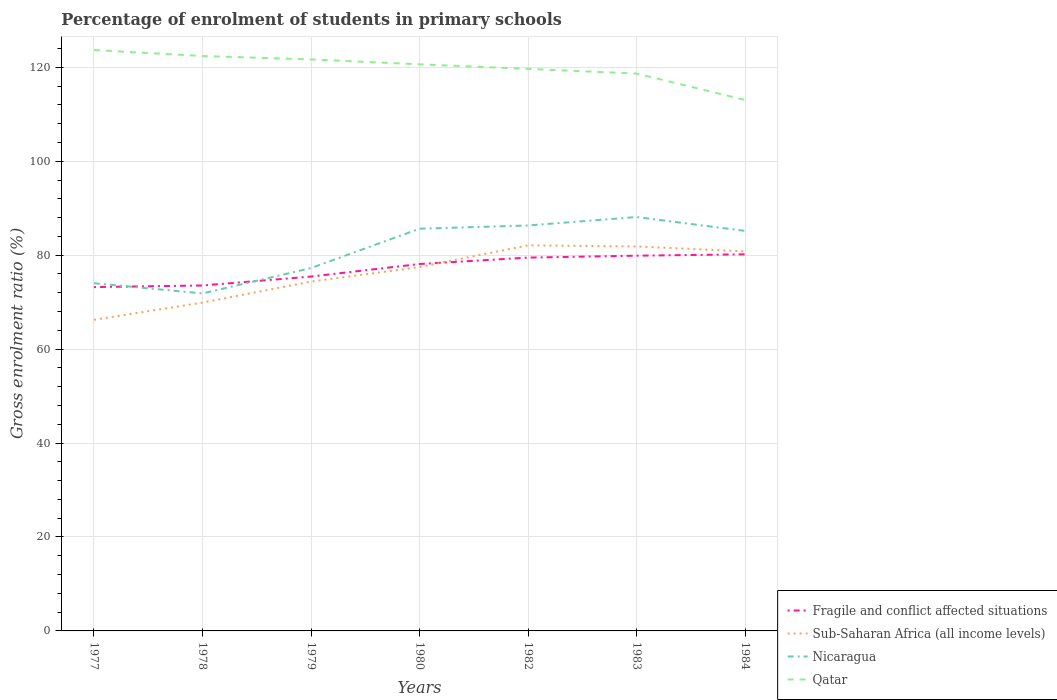Is the number of lines equal to the number of legend labels?
Your answer should be compact. Yes. Across all years, what is the maximum percentage of students enrolled in primary schools in Qatar?
Ensure brevity in your answer.  113.06. What is the total percentage of students enrolled in primary schools in Sub-Saharan Africa (all income levels) in the graph?
Provide a succinct answer. -7.72. What is the difference between the highest and the second highest percentage of students enrolled in primary schools in Fragile and conflict affected situations?
Your answer should be very brief. 6.98. What is the difference between the highest and the lowest percentage of students enrolled in primary schools in Fragile and conflict affected situations?
Give a very brief answer. 4. How many lines are there?
Offer a terse response. 4. Are the values on the major ticks of Y-axis written in scientific E-notation?
Your answer should be compact. No. Where does the legend appear in the graph?
Keep it short and to the point. Bottom right. How many legend labels are there?
Provide a short and direct response. 4. How are the legend labels stacked?
Keep it short and to the point. Vertical. What is the title of the graph?
Your answer should be compact. Percentage of enrolment of students in primary schools. Does "Lower middle income" appear as one of the legend labels in the graph?
Your response must be concise. No. What is the Gross enrolment ratio (%) in Fragile and conflict affected situations in 1977?
Offer a terse response. 73.21. What is the Gross enrolment ratio (%) of Sub-Saharan Africa (all income levels) in 1977?
Offer a terse response. 66.25. What is the Gross enrolment ratio (%) in Nicaragua in 1977?
Ensure brevity in your answer.  74.04. What is the Gross enrolment ratio (%) of Qatar in 1977?
Ensure brevity in your answer.  123.68. What is the Gross enrolment ratio (%) in Fragile and conflict affected situations in 1978?
Offer a very short reply. 73.55. What is the Gross enrolment ratio (%) of Sub-Saharan Africa (all income levels) in 1978?
Your answer should be very brief. 69.91. What is the Gross enrolment ratio (%) of Nicaragua in 1978?
Keep it short and to the point. 71.86. What is the Gross enrolment ratio (%) in Qatar in 1978?
Offer a terse response. 122.42. What is the Gross enrolment ratio (%) of Fragile and conflict affected situations in 1979?
Provide a succinct answer. 75.46. What is the Gross enrolment ratio (%) of Sub-Saharan Africa (all income levels) in 1979?
Keep it short and to the point. 74.39. What is the Gross enrolment ratio (%) of Nicaragua in 1979?
Make the answer very short. 77.27. What is the Gross enrolment ratio (%) in Qatar in 1979?
Make the answer very short. 121.69. What is the Gross enrolment ratio (%) of Fragile and conflict affected situations in 1980?
Offer a terse response. 78.13. What is the Gross enrolment ratio (%) of Sub-Saharan Africa (all income levels) in 1980?
Give a very brief answer. 77.48. What is the Gross enrolment ratio (%) in Nicaragua in 1980?
Provide a succinct answer. 85.64. What is the Gross enrolment ratio (%) of Qatar in 1980?
Give a very brief answer. 120.65. What is the Gross enrolment ratio (%) in Fragile and conflict affected situations in 1982?
Your answer should be compact. 79.49. What is the Gross enrolment ratio (%) in Sub-Saharan Africa (all income levels) in 1982?
Provide a short and direct response. 82.11. What is the Gross enrolment ratio (%) in Nicaragua in 1982?
Give a very brief answer. 86.33. What is the Gross enrolment ratio (%) in Qatar in 1982?
Offer a very short reply. 119.67. What is the Gross enrolment ratio (%) in Fragile and conflict affected situations in 1983?
Provide a succinct answer. 79.9. What is the Gross enrolment ratio (%) in Sub-Saharan Africa (all income levels) in 1983?
Ensure brevity in your answer.  81.86. What is the Gross enrolment ratio (%) in Nicaragua in 1983?
Your answer should be very brief. 88.13. What is the Gross enrolment ratio (%) in Qatar in 1983?
Offer a terse response. 118.68. What is the Gross enrolment ratio (%) in Fragile and conflict affected situations in 1984?
Give a very brief answer. 80.2. What is the Gross enrolment ratio (%) of Sub-Saharan Africa (all income levels) in 1984?
Make the answer very short. 80.81. What is the Gross enrolment ratio (%) of Nicaragua in 1984?
Your response must be concise. 85.18. What is the Gross enrolment ratio (%) of Qatar in 1984?
Offer a terse response. 113.06. Across all years, what is the maximum Gross enrolment ratio (%) in Fragile and conflict affected situations?
Provide a succinct answer. 80.2. Across all years, what is the maximum Gross enrolment ratio (%) of Sub-Saharan Africa (all income levels)?
Provide a succinct answer. 82.11. Across all years, what is the maximum Gross enrolment ratio (%) in Nicaragua?
Offer a terse response. 88.13. Across all years, what is the maximum Gross enrolment ratio (%) of Qatar?
Provide a short and direct response. 123.68. Across all years, what is the minimum Gross enrolment ratio (%) in Fragile and conflict affected situations?
Offer a terse response. 73.21. Across all years, what is the minimum Gross enrolment ratio (%) in Sub-Saharan Africa (all income levels)?
Give a very brief answer. 66.25. Across all years, what is the minimum Gross enrolment ratio (%) in Nicaragua?
Offer a terse response. 71.86. Across all years, what is the minimum Gross enrolment ratio (%) of Qatar?
Your answer should be compact. 113.06. What is the total Gross enrolment ratio (%) in Fragile and conflict affected situations in the graph?
Your answer should be very brief. 539.94. What is the total Gross enrolment ratio (%) of Sub-Saharan Africa (all income levels) in the graph?
Ensure brevity in your answer.  532.8. What is the total Gross enrolment ratio (%) of Nicaragua in the graph?
Your response must be concise. 568.45. What is the total Gross enrolment ratio (%) in Qatar in the graph?
Make the answer very short. 839.85. What is the difference between the Gross enrolment ratio (%) of Fragile and conflict affected situations in 1977 and that in 1978?
Your answer should be very brief. -0.34. What is the difference between the Gross enrolment ratio (%) of Sub-Saharan Africa (all income levels) in 1977 and that in 1978?
Keep it short and to the point. -3.66. What is the difference between the Gross enrolment ratio (%) in Nicaragua in 1977 and that in 1978?
Your answer should be compact. 2.18. What is the difference between the Gross enrolment ratio (%) in Qatar in 1977 and that in 1978?
Offer a very short reply. 1.27. What is the difference between the Gross enrolment ratio (%) of Fragile and conflict affected situations in 1977 and that in 1979?
Your answer should be very brief. -2.24. What is the difference between the Gross enrolment ratio (%) of Sub-Saharan Africa (all income levels) in 1977 and that in 1979?
Provide a short and direct response. -8.14. What is the difference between the Gross enrolment ratio (%) in Nicaragua in 1977 and that in 1979?
Make the answer very short. -3.23. What is the difference between the Gross enrolment ratio (%) of Qatar in 1977 and that in 1979?
Give a very brief answer. 1.99. What is the difference between the Gross enrolment ratio (%) in Fragile and conflict affected situations in 1977 and that in 1980?
Offer a terse response. -4.91. What is the difference between the Gross enrolment ratio (%) of Sub-Saharan Africa (all income levels) in 1977 and that in 1980?
Keep it short and to the point. -11.23. What is the difference between the Gross enrolment ratio (%) in Nicaragua in 1977 and that in 1980?
Offer a terse response. -11.6. What is the difference between the Gross enrolment ratio (%) in Qatar in 1977 and that in 1980?
Keep it short and to the point. 3.03. What is the difference between the Gross enrolment ratio (%) in Fragile and conflict affected situations in 1977 and that in 1982?
Offer a very short reply. -6.28. What is the difference between the Gross enrolment ratio (%) in Sub-Saharan Africa (all income levels) in 1977 and that in 1982?
Ensure brevity in your answer.  -15.86. What is the difference between the Gross enrolment ratio (%) in Nicaragua in 1977 and that in 1982?
Give a very brief answer. -12.29. What is the difference between the Gross enrolment ratio (%) of Qatar in 1977 and that in 1982?
Ensure brevity in your answer.  4.01. What is the difference between the Gross enrolment ratio (%) of Fragile and conflict affected situations in 1977 and that in 1983?
Provide a short and direct response. -6.68. What is the difference between the Gross enrolment ratio (%) of Sub-Saharan Africa (all income levels) in 1977 and that in 1983?
Your answer should be compact. -15.61. What is the difference between the Gross enrolment ratio (%) of Nicaragua in 1977 and that in 1983?
Offer a very short reply. -14.09. What is the difference between the Gross enrolment ratio (%) in Qatar in 1977 and that in 1983?
Give a very brief answer. 5. What is the difference between the Gross enrolment ratio (%) of Fragile and conflict affected situations in 1977 and that in 1984?
Your answer should be compact. -6.98. What is the difference between the Gross enrolment ratio (%) of Sub-Saharan Africa (all income levels) in 1977 and that in 1984?
Give a very brief answer. -14.56. What is the difference between the Gross enrolment ratio (%) in Nicaragua in 1977 and that in 1984?
Ensure brevity in your answer.  -11.14. What is the difference between the Gross enrolment ratio (%) of Qatar in 1977 and that in 1984?
Offer a terse response. 10.63. What is the difference between the Gross enrolment ratio (%) in Fragile and conflict affected situations in 1978 and that in 1979?
Provide a short and direct response. -1.9. What is the difference between the Gross enrolment ratio (%) in Sub-Saharan Africa (all income levels) in 1978 and that in 1979?
Provide a succinct answer. -4.48. What is the difference between the Gross enrolment ratio (%) of Nicaragua in 1978 and that in 1979?
Offer a terse response. -5.41. What is the difference between the Gross enrolment ratio (%) of Qatar in 1978 and that in 1979?
Ensure brevity in your answer.  0.73. What is the difference between the Gross enrolment ratio (%) of Fragile and conflict affected situations in 1978 and that in 1980?
Offer a terse response. -4.57. What is the difference between the Gross enrolment ratio (%) in Sub-Saharan Africa (all income levels) in 1978 and that in 1980?
Your response must be concise. -7.57. What is the difference between the Gross enrolment ratio (%) of Nicaragua in 1978 and that in 1980?
Ensure brevity in your answer.  -13.78. What is the difference between the Gross enrolment ratio (%) in Qatar in 1978 and that in 1980?
Make the answer very short. 1.77. What is the difference between the Gross enrolment ratio (%) in Fragile and conflict affected situations in 1978 and that in 1982?
Offer a terse response. -5.94. What is the difference between the Gross enrolment ratio (%) in Sub-Saharan Africa (all income levels) in 1978 and that in 1982?
Ensure brevity in your answer.  -12.2. What is the difference between the Gross enrolment ratio (%) of Nicaragua in 1978 and that in 1982?
Keep it short and to the point. -14.47. What is the difference between the Gross enrolment ratio (%) in Qatar in 1978 and that in 1982?
Your response must be concise. 2.74. What is the difference between the Gross enrolment ratio (%) in Fragile and conflict affected situations in 1978 and that in 1983?
Your answer should be very brief. -6.34. What is the difference between the Gross enrolment ratio (%) of Sub-Saharan Africa (all income levels) in 1978 and that in 1983?
Offer a very short reply. -11.95. What is the difference between the Gross enrolment ratio (%) of Nicaragua in 1978 and that in 1983?
Your answer should be very brief. -16.27. What is the difference between the Gross enrolment ratio (%) of Qatar in 1978 and that in 1983?
Provide a succinct answer. 3.73. What is the difference between the Gross enrolment ratio (%) of Fragile and conflict affected situations in 1978 and that in 1984?
Your answer should be very brief. -6.64. What is the difference between the Gross enrolment ratio (%) in Sub-Saharan Africa (all income levels) in 1978 and that in 1984?
Offer a terse response. -10.9. What is the difference between the Gross enrolment ratio (%) in Nicaragua in 1978 and that in 1984?
Provide a short and direct response. -13.32. What is the difference between the Gross enrolment ratio (%) of Qatar in 1978 and that in 1984?
Provide a succinct answer. 9.36. What is the difference between the Gross enrolment ratio (%) in Fragile and conflict affected situations in 1979 and that in 1980?
Keep it short and to the point. -2.67. What is the difference between the Gross enrolment ratio (%) in Sub-Saharan Africa (all income levels) in 1979 and that in 1980?
Provide a short and direct response. -3.09. What is the difference between the Gross enrolment ratio (%) of Nicaragua in 1979 and that in 1980?
Provide a succinct answer. -8.37. What is the difference between the Gross enrolment ratio (%) in Qatar in 1979 and that in 1980?
Offer a terse response. 1.04. What is the difference between the Gross enrolment ratio (%) of Fragile and conflict affected situations in 1979 and that in 1982?
Provide a succinct answer. -4.03. What is the difference between the Gross enrolment ratio (%) in Sub-Saharan Africa (all income levels) in 1979 and that in 1982?
Provide a succinct answer. -7.72. What is the difference between the Gross enrolment ratio (%) of Nicaragua in 1979 and that in 1982?
Provide a succinct answer. -9.06. What is the difference between the Gross enrolment ratio (%) of Qatar in 1979 and that in 1982?
Provide a succinct answer. 2.02. What is the difference between the Gross enrolment ratio (%) in Fragile and conflict affected situations in 1979 and that in 1983?
Ensure brevity in your answer.  -4.44. What is the difference between the Gross enrolment ratio (%) in Sub-Saharan Africa (all income levels) in 1979 and that in 1983?
Offer a very short reply. -7.48. What is the difference between the Gross enrolment ratio (%) of Nicaragua in 1979 and that in 1983?
Keep it short and to the point. -10.86. What is the difference between the Gross enrolment ratio (%) in Qatar in 1979 and that in 1983?
Your answer should be compact. 3.01. What is the difference between the Gross enrolment ratio (%) in Fragile and conflict affected situations in 1979 and that in 1984?
Ensure brevity in your answer.  -4.74. What is the difference between the Gross enrolment ratio (%) of Sub-Saharan Africa (all income levels) in 1979 and that in 1984?
Provide a succinct answer. -6.42. What is the difference between the Gross enrolment ratio (%) of Nicaragua in 1979 and that in 1984?
Your response must be concise. -7.91. What is the difference between the Gross enrolment ratio (%) in Qatar in 1979 and that in 1984?
Make the answer very short. 8.63. What is the difference between the Gross enrolment ratio (%) of Fragile and conflict affected situations in 1980 and that in 1982?
Give a very brief answer. -1.36. What is the difference between the Gross enrolment ratio (%) of Sub-Saharan Africa (all income levels) in 1980 and that in 1982?
Offer a very short reply. -4.63. What is the difference between the Gross enrolment ratio (%) of Nicaragua in 1980 and that in 1982?
Give a very brief answer. -0.69. What is the difference between the Gross enrolment ratio (%) in Qatar in 1980 and that in 1982?
Ensure brevity in your answer.  0.98. What is the difference between the Gross enrolment ratio (%) in Fragile and conflict affected situations in 1980 and that in 1983?
Ensure brevity in your answer.  -1.77. What is the difference between the Gross enrolment ratio (%) in Sub-Saharan Africa (all income levels) in 1980 and that in 1983?
Your answer should be very brief. -4.38. What is the difference between the Gross enrolment ratio (%) of Nicaragua in 1980 and that in 1983?
Provide a succinct answer. -2.49. What is the difference between the Gross enrolment ratio (%) in Qatar in 1980 and that in 1983?
Keep it short and to the point. 1.97. What is the difference between the Gross enrolment ratio (%) of Fragile and conflict affected situations in 1980 and that in 1984?
Your answer should be very brief. -2.07. What is the difference between the Gross enrolment ratio (%) of Sub-Saharan Africa (all income levels) in 1980 and that in 1984?
Your response must be concise. -3.33. What is the difference between the Gross enrolment ratio (%) of Nicaragua in 1980 and that in 1984?
Your answer should be very brief. 0.46. What is the difference between the Gross enrolment ratio (%) in Qatar in 1980 and that in 1984?
Offer a terse response. 7.59. What is the difference between the Gross enrolment ratio (%) of Fragile and conflict affected situations in 1982 and that in 1983?
Provide a short and direct response. -0.41. What is the difference between the Gross enrolment ratio (%) of Sub-Saharan Africa (all income levels) in 1982 and that in 1983?
Offer a terse response. 0.24. What is the difference between the Gross enrolment ratio (%) in Nicaragua in 1982 and that in 1983?
Provide a succinct answer. -1.8. What is the difference between the Gross enrolment ratio (%) of Qatar in 1982 and that in 1983?
Offer a very short reply. 0.99. What is the difference between the Gross enrolment ratio (%) of Fragile and conflict affected situations in 1982 and that in 1984?
Keep it short and to the point. -0.71. What is the difference between the Gross enrolment ratio (%) of Sub-Saharan Africa (all income levels) in 1982 and that in 1984?
Your answer should be very brief. 1.3. What is the difference between the Gross enrolment ratio (%) in Nicaragua in 1982 and that in 1984?
Provide a succinct answer. 1.15. What is the difference between the Gross enrolment ratio (%) of Qatar in 1982 and that in 1984?
Provide a succinct answer. 6.62. What is the difference between the Gross enrolment ratio (%) of Fragile and conflict affected situations in 1983 and that in 1984?
Your answer should be very brief. -0.3. What is the difference between the Gross enrolment ratio (%) in Sub-Saharan Africa (all income levels) in 1983 and that in 1984?
Your answer should be very brief. 1.06. What is the difference between the Gross enrolment ratio (%) in Nicaragua in 1983 and that in 1984?
Keep it short and to the point. 2.95. What is the difference between the Gross enrolment ratio (%) in Qatar in 1983 and that in 1984?
Keep it short and to the point. 5.63. What is the difference between the Gross enrolment ratio (%) in Fragile and conflict affected situations in 1977 and the Gross enrolment ratio (%) in Sub-Saharan Africa (all income levels) in 1978?
Offer a very short reply. 3.3. What is the difference between the Gross enrolment ratio (%) of Fragile and conflict affected situations in 1977 and the Gross enrolment ratio (%) of Nicaragua in 1978?
Offer a very short reply. 1.35. What is the difference between the Gross enrolment ratio (%) in Fragile and conflict affected situations in 1977 and the Gross enrolment ratio (%) in Qatar in 1978?
Your answer should be compact. -49.2. What is the difference between the Gross enrolment ratio (%) in Sub-Saharan Africa (all income levels) in 1977 and the Gross enrolment ratio (%) in Nicaragua in 1978?
Keep it short and to the point. -5.61. What is the difference between the Gross enrolment ratio (%) of Sub-Saharan Africa (all income levels) in 1977 and the Gross enrolment ratio (%) of Qatar in 1978?
Your response must be concise. -56.17. What is the difference between the Gross enrolment ratio (%) in Nicaragua in 1977 and the Gross enrolment ratio (%) in Qatar in 1978?
Provide a short and direct response. -48.37. What is the difference between the Gross enrolment ratio (%) of Fragile and conflict affected situations in 1977 and the Gross enrolment ratio (%) of Sub-Saharan Africa (all income levels) in 1979?
Make the answer very short. -1.17. What is the difference between the Gross enrolment ratio (%) in Fragile and conflict affected situations in 1977 and the Gross enrolment ratio (%) in Nicaragua in 1979?
Give a very brief answer. -4.05. What is the difference between the Gross enrolment ratio (%) of Fragile and conflict affected situations in 1977 and the Gross enrolment ratio (%) of Qatar in 1979?
Keep it short and to the point. -48.48. What is the difference between the Gross enrolment ratio (%) in Sub-Saharan Africa (all income levels) in 1977 and the Gross enrolment ratio (%) in Nicaragua in 1979?
Ensure brevity in your answer.  -11.02. What is the difference between the Gross enrolment ratio (%) of Sub-Saharan Africa (all income levels) in 1977 and the Gross enrolment ratio (%) of Qatar in 1979?
Keep it short and to the point. -55.44. What is the difference between the Gross enrolment ratio (%) of Nicaragua in 1977 and the Gross enrolment ratio (%) of Qatar in 1979?
Your answer should be compact. -47.65. What is the difference between the Gross enrolment ratio (%) of Fragile and conflict affected situations in 1977 and the Gross enrolment ratio (%) of Sub-Saharan Africa (all income levels) in 1980?
Keep it short and to the point. -4.26. What is the difference between the Gross enrolment ratio (%) of Fragile and conflict affected situations in 1977 and the Gross enrolment ratio (%) of Nicaragua in 1980?
Offer a very short reply. -12.43. What is the difference between the Gross enrolment ratio (%) of Fragile and conflict affected situations in 1977 and the Gross enrolment ratio (%) of Qatar in 1980?
Ensure brevity in your answer.  -47.44. What is the difference between the Gross enrolment ratio (%) in Sub-Saharan Africa (all income levels) in 1977 and the Gross enrolment ratio (%) in Nicaragua in 1980?
Keep it short and to the point. -19.39. What is the difference between the Gross enrolment ratio (%) of Sub-Saharan Africa (all income levels) in 1977 and the Gross enrolment ratio (%) of Qatar in 1980?
Give a very brief answer. -54.4. What is the difference between the Gross enrolment ratio (%) of Nicaragua in 1977 and the Gross enrolment ratio (%) of Qatar in 1980?
Make the answer very short. -46.61. What is the difference between the Gross enrolment ratio (%) of Fragile and conflict affected situations in 1977 and the Gross enrolment ratio (%) of Sub-Saharan Africa (all income levels) in 1982?
Your response must be concise. -8.89. What is the difference between the Gross enrolment ratio (%) of Fragile and conflict affected situations in 1977 and the Gross enrolment ratio (%) of Nicaragua in 1982?
Your answer should be compact. -13.12. What is the difference between the Gross enrolment ratio (%) of Fragile and conflict affected situations in 1977 and the Gross enrolment ratio (%) of Qatar in 1982?
Your answer should be compact. -46.46. What is the difference between the Gross enrolment ratio (%) of Sub-Saharan Africa (all income levels) in 1977 and the Gross enrolment ratio (%) of Nicaragua in 1982?
Provide a succinct answer. -20.08. What is the difference between the Gross enrolment ratio (%) of Sub-Saharan Africa (all income levels) in 1977 and the Gross enrolment ratio (%) of Qatar in 1982?
Your response must be concise. -53.42. What is the difference between the Gross enrolment ratio (%) in Nicaragua in 1977 and the Gross enrolment ratio (%) in Qatar in 1982?
Offer a very short reply. -45.63. What is the difference between the Gross enrolment ratio (%) in Fragile and conflict affected situations in 1977 and the Gross enrolment ratio (%) in Sub-Saharan Africa (all income levels) in 1983?
Offer a terse response. -8.65. What is the difference between the Gross enrolment ratio (%) in Fragile and conflict affected situations in 1977 and the Gross enrolment ratio (%) in Nicaragua in 1983?
Offer a terse response. -14.92. What is the difference between the Gross enrolment ratio (%) in Fragile and conflict affected situations in 1977 and the Gross enrolment ratio (%) in Qatar in 1983?
Your answer should be compact. -45.47. What is the difference between the Gross enrolment ratio (%) in Sub-Saharan Africa (all income levels) in 1977 and the Gross enrolment ratio (%) in Nicaragua in 1983?
Provide a succinct answer. -21.88. What is the difference between the Gross enrolment ratio (%) in Sub-Saharan Africa (all income levels) in 1977 and the Gross enrolment ratio (%) in Qatar in 1983?
Provide a short and direct response. -52.43. What is the difference between the Gross enrolment ratio (%) of Nicaragua in 1977 and the Gross enrolment ratio (%) of Qatar in 1983?
Your response must be concise. -44.64. What is the difference between the Gross enrolment ratio (%) of Fragile and conflict affected situations in 1977 and the Gross enrolment ratio (%) of Sub-Saharan Africa (all income levels) in 1984?
Make the answer very short. -7.59. What is the difference between the Gross enrolment ratio (%) of Fragile and conflict affected situations in 1977 and the Gross enrolment ratio (%) of Nicaragua in 1984?
Provide a short and direct response. -11.97. What is the difference between the Gross enrolment ratio (%) of Fragile and conflict affected situations in 1977 and the Gross enrolment ratio (%) of Qatar in 1984?
Your answer should be compact. -39.84. What is the difference between the Gross enrolment ratio (%) of Sub-Saharan Africa (all income levels) in 1977 and the Gross enrolment ratio (%) of Nicaragua in 1984?
Keep it short and to the point. -18.93. What is the difference between the Gross enrolment ratio (%) in Sub-Saharan Africa (all income levels) in 1977 and the Gross enrolment ratio (%) in Qatar in 1984?
Your answer should be very brief. -46.8. What is the difference between the Gross enrolment ratio (%) of Nicaragua in 1977 and the Gross enrolment ratio (%) of Qatar in 1984?
Ensure brevity in your answer.  -39.01. What is the difference between the Gross enrolment ratio (%) in Fragile and conflict affected situations in 1978 and the Gross enrolment ratio (%) in Sub-Saharan Africa (all income levels) in 1979?
Ensure brevity in your answer.  -0.83. What is the difference between the Gross enrolment ratio (%) of Fragile and conflict affected situations in 1978 and the Gross enrolment ratio (%) of Nicaragua in 1979?
Your response must be concise. -3.71. What is the difference between the Gross enrolment ratio (%) in Fragile and conflict affected situations in 1978 and the Gross enrolment ratio (%) in Qatar in 1979?
Your response must be concise. -48.14. What is the difference between the Gross enrolment ratio (%) of Sub-Saharan Africa (all income levels) in 1978 and the Gross enrolment ratio (%) of Nicaragua in 1979?
Provide a short and direct response. -7.36. What is the difference between the Gross enrolment ratio (%) of Sub-Saharan Africa (all income levels) in 1978 and the Gross enrolment ratio (%) of Qatar in 1979?
Give a very brief answer. -51.78. What is the difference between the Gross enrolment ratio (%) of Nicaragua in 1978 and the Gross enrolment ratio (%) of Qatar in 1979?
Your answer should be very brief. -49.83. What is the difference between the Gross enrolment ratio (%) in Fragile and conflict affected situations in 1978 and the Gross enrolment ratio (%) in Sub-Saharan Africa (all income levels) in 1980?
Offer a very short reply. -3.92. What is the difference between the Gross enrolment ratio (%) in Fragile and conflict affected situations in 1978 and the Gross enrolment ratio (%) in Nicaragua in 1980?
Your response must be concise. -12.09. What is the difference between the Gross enrolment ratio (%) in Fragile and conflict affected situations in 1978 and the Gross enrolment ratio (%) in Qatar in 1980?
Make the answer very short. -47.09. What is the difference between the Gross enrolment ratio (%) in Sub-Saharan Africa (all income levels) in 1978 and the Gross enrolment ratio (%) in Nicaragua in 1980?
Offer a very short reply. -15.73. What is the difference between the Gross enrolment ratio (%) in Sub-Saharan Africa (all income levels) in 1978 and the Gross enrolment ratio (%) in Qatar in 1980?
Ensure brevity in your answer.  -50.74. What is the difference between the Gross enrolment ratio (%) of Nicaragua in 1978 and the Gross enrolment ratio (%) of Qatar in 1980?
Ensure brevity in your answer.  -48.79. What is the difference between the Gross enrolment ratio (%) of Fragile and conflict affected situations in 1978 and the Gross enrolment ratio (%) of Sub-Saharan Africa (all income levels) in 1982?
Make the answer very short. -8.55. What is the difference between the Gross enrolment ratio (%) of Fragile and conflict affected situations in 1978 and the Gross enrolment ratio (%) of Nicaragua in 1982?
Give a very brief answer. -12.77. What is the difference between the Gross enrolment ratio (%) of Fragile and conflict affected situations in 1978 and the Gross enrolment ratio (%) of Qatar in 1982?
Your answer should be compact. -46.12. What is the difference between the Gross enrolment ratio (%) of Sub-Saharan Africa (all income levels) in 1978 and the Gross enrolment ratio (%) of Nicaragua in 1982?
Offer a very short reply. -16.42. What is the difference between the Gross enrolment ratio (%) of Sub-Saharan Africa (all income levels) in 1978 and the Gross enrolment ratio (%) of Qatar in 1982?
Make the answer very short. -49.76. What is the difference between the Gross enrolment ratio (%) in Nicaragua in 1978 and the Gross enrolment ratio (%) in Qatar in 1982?
Provide a short and direct response. -47.81. What is the difference between the Gross enrolment ratio (%) in Fragile and conflict affected situations in 1978 and the Gross enrolment ratio (%) in Sub-Saharan Africa (all income levels) in 1983?
Give a very brief answer. -8.31. What is the difference between the Gross enrolment ratio (%) in Fragile and conflict affected situations in 1978 and the Gross enrolment ratio (%) in Nicaragua in 1983?
Keep it short and to the point. -14.58. What is the difference between the Gross enrolment ratio (%) in Fragile and conflict affected situations in 1978 and the Gross enrolment ratio (%) in Qatar in 1983?
Ensure brevity in your answer.  -45.13. What is the difference between the Gross enrolment ratio (%) of Sub-Saharan Africa (all income levels) in 1978 and the Gross enrolment ratio (%) of Nicaragua in 1983?
Ensure brevity in your answer.  -18.22. What is the difference between the Gross enrolment ratio (%) in Sub-Saharan Africa (all income levels) in 1978 and the Gross enrolment ratio (%) in Qatar in 1983?
Your answer should be very brief. -48.77. What is the difference between the Gross enrolment ratio (%) of Nicaragua in 1978 and the Gross enrolment ratio (%) of Qatar in 1983?
Keep it short and to the point. -46.82. What is the difference between the Gross enrolment ratio (%) of Fragile and conflict affected situations in 1978 and the Gross enrolment ratio (%) of Sub-Saharan Africa (all income levels) in 1984?
Your answer should be compact. -7.25. What is the difference between the Gross enrolment ratio (%) in Fragile and conflict affected situations in 1978 and the Gross enrolment ratio (%) in Nicaragua in 1984?
Your response must be concise. -11.62. What is the difference between the Gross enrolment ratio (%) of Fragile and conflict affected situations in 1978 and the Gross enrolment ratio (%) of Qatar in 1984?
Provide a succinct answer. -39.5. What is the difference between the Gross enrolment ratio (%) in Sub-Saharan Africa (all income levels) in 1978 and the Gross enrolment ratio (%) in Nicaragua in 1984?
Make the answer very short. -15.27. What is the difference between the Gross enrolment ratio (%) of Sub-Saharan Africa (all income levels) in 1978 and the Gross enrolment ratio (%) of Qatar in 1984?
Your answer should be compact. -43.14. What is the difference between the Gross enrolment ratio (%) in Nicaragua in 1978 and the Gross enrolment ratio (%) in Qatar in 1984?
Provide a succinct answer. -41.2. What is the difference between the Gross enrolment ratio (%) of Fragile and conflict affected situations in 1979 and the Gross enrolment ratio (%) of Sub-Saharan Africa (all income levels) in 1980?
Provide a short and direct response. -2.02. What is the difference between the Gross enrolment ratio (%) of Fragile and conflict affected situations in 1979 and the Gross enrolment ratio (%) of Nicaragua in 1980?
Offer a terse response. -10.18. What is the difference between the Gross enrolment ratio (%) in Fragile and conflict affected situations in 1979 and the Gross enrolment ratio (%) in Qatar in 1980?
Provide a succinct answer. -45.19. What is the difference between the Gross enrolment ratio (%) of Sub-Saharan Africa (all income levels) in 1979 and the Gross enrolment ratio (%) of Nicaragua in 1980?
Ensure brevity in your answer.  -11.26. What is the difference between the Gross enrolment ratio (%) of Sub-Saharan Africa (all income levels) in 1979 and the Gross enrolment ratio (%) of Qatar in 1980?
Ensure brevity in your answer.  -46.26. What is the difference between the Gross enrolment ratio (%) of Nicaragua in 1979 and the Gross enrolment ratio (%) of Qatar in 1980?
Ensure brevity in your answer.  -43.38. What is the difference between the Gross enrolment ratio (%) in Fragile and conflict affected situations in 1979 and the Gross enrolment ratio (%) in Sub-Saharan Africa (all income levels) in 1982?
Provide a succinct answer. -6.65. What is the difference between the Gross enrolment ratio (%) of Fragile and conflict affected situations in 1979 and the Gross enrolment ratio (%) of Nicaragua in 1982?
Offer a very short reply. -10.87. What is the difference between the Gross enrolment ratio (%) in Fragile and conflict affected situations in 1979 and the Gross enrolment ratio (%) in Qatar in 1982?
Your answer should be very brief. -44.22. What is the difference between the Gross enrolment ratio (%) of Sub-Saharan Africa (all income levels) in 1979 and the Gross enrolment ratio (%) of Nicaragua in 1982?
Make the answer very short. -11.94. What is the difference between the Gross enrolment ratio (%) in Sub-Saharan Africa (all income levels) in 1979 and the Gross enrolment ratio (%) in Qatar in 1982?
Offer a terse response. -45.29. What is the difference between the Gross enrolment ratio (%) in Nicaragua in 1979 and the Gross enrolment ratio (%) in Qatar in 1982?
Provide a succinct answer. -42.41. What is the difference between the Gross enrolment ratio (%) of Fragile and conflict affected situations in 1979 and the Gross enrolment ratio (%) of Sub-Saharan Africa (all income levels) in 1983?
Offer a very short reply. -6.41. What is the difference between the Gross enrolment ratio (%) in Fragile and conflict affected situations in 1979 and the Gross enrolment ratio (%) in Nicaragua in 1983?
Your response must be concise. -12.67. What is the difference between the Gross enrolment ratio (%) of Fragile and conflict affected situations in 1979 and the Gross enrolment ratio (%) of Qatar in 1983?
Make the answer very short. -43.23. What is the difference between the Gross enrolment ratio (%) of Sub-Saharan Africa (all income levels) in 1979 and the Gross enrolment ratio (%) of Nicaragua in 1983?
Keep it short and to the point. -13.75. What is the difference between the Gross enrolment ratio (%) in Sub-Saharan Africa (all income levels) in 1979 and the Gross enrolment ratio (%) in Qatar in 1983?
Provide a succinct answer. -44.3. What is the difference between the Gross enrolment ratio (%) in Nicaragua in 1979 and the Gross enrolment ratio (%) in Qatar in 1983?
Provide a succinct answer. -41.42. What is the difference between the Gross enrolment ratio (%) in Fragile and conflict affected situations in 1979 and the Gross enrolment ratio (%) in Sub-Saharan Africa (all income levels) in 1984?
Make the answer very short. -5.35. What is the difference between the Gross enrolment ratio (%) of Fragile and conflict affected situations in 1979 and the Gross enrolment ratio (%) of Nicaragua in 1984?
Provide a short and direct response. -9.72. What is the difference between the Gross enrolment ratio (%) in Fragile and conflict affected situations in 1979 and the Gross enrolment ratio (%) in Qatar in 1984?
Offer a very short reply. -37.6. What is the difference between the Gross enrolment ratio (%) of Sub-Saharan Africa (all income levels) in 1979 and the Gross enrolment ratio (%) of Nicaragua in 1984?
Your answer should be very brief. -10.79. What is the difference between the Gross enrolment ratio (%) in Sub-Saharan Africa (all income levels) in 1979 and the Gross enrolment ratio (%) in Qatar in 1984?
Provide a short and direct response. -38.67. What is the difference between the Gross enrolment ratio (%) in Nicaragua in 1979 and the Gross enrolment ratio (%) in Qatar in 1984?
Ensure brevity in your answer.  -35.79. What is the difference between the Gross enrolment ratio (%) of Fragile and conflict affected situations in 1980 and the Gross enrolment ratio (%) of Sub-Saharan Africa (all income levels) in 1982?
Provide a succinct answer. -3.98. What is the difference between the Gross enrolment ratio (%) of Fragile and conflict affected situations in 1980 and the Gross enrolment ratio (%) of Nicaragua in 1982?
Make the answer very short. -8.2. What is the difference between the Gross enrolment ratio (%) of Fragile and conflict affected situations in 1980 and the Gross enrolment ratio (%) of Qatar in 1982?
Offer a terse response. -41.55. What is the difference between the Gross enrolment ratio (%) in Sub-Saharan Africa (all income levels) in 1980 and the Gross enrolment ratio (%) in Nicaragua in 1982?
Your answer should be very brief. -8.85. What is the difference between the Gross enrolment ratio (%) of Sub-Saharan Africa (all income levels) in 1980 and the Gross enrolment ratio (%) of Qatar in 1982?
Give a very brief answer. -42.19. What is the difference between the Gross enrolment ratio (%) of Nicaragua in 1980 and the Gross enrolment ratio (%) of Qatar in 1982?
Keep it short and to the point. -34.03. What is the difference between the Gross enrolment ratio (%) in Fragile and conflict affected situations in 1980 and the Gross enrolment ratio (%) in Sub-Saharan Africa (all income levels) in 1983?
Your response must be concise. -3.74. What is the difference between the Gross enrolment ratio (%) in Fragile and conflict affected situations in 1980 and the Gross enrolment ratio (%) in Nicaragua in 1983?
Your answer should be compact. -10.01. What is the difference between the Gross enrolment ratio (%) of Fragile and conflict affected situations in 1980 and the Gross enrolment ratio (%) of Qatar in 1983?
Give a very brief answer. -40.56. What is the difference between the Gross enrolment ratio (%) of Sub-Saharan Africa (all income levels) in 1980 and the Gross enrolment ratio (%) of Nicaragua in 1983?
Offer a very short reply. -10.65. What is the difference between the Gross enrolment ratio (%) in Sub-Saharan Africa (all income levels) in 1980 and the Gross enrolment ratio (%) in Qatar in 1983?
Offer a terse response. -41.2. What is the difference between the Gross enrolment ratio (%) of Nicaragua in 1980 and the Gross enrolment ratio (%) of Qatar in 1983?
Provide a short and direct response. -33.04. What is the difference between the Gross enrolment ratio (%) in Fragile and conflict affected situations in 1980 and the Gross enrolment ratio (%) in Sub-Saharan Africa (all income levels) in 1984?
Make the answer very short. -2.68. What is the difference between the Gross enrolment ratio (%) of Fragile and conflict affected situations in 1980 and the Gross enrolment ratio (%) of Nicaragua in 1984?
Offer a terse response. -7.05. What is the difference between the Gross enrolment ratio (%) in Fragile and conflict affected situations in 1980 and the Gross enrolment ratio (%) in Qatar in 1984?
Ensure brevity in your answer.  -34.93. What is the difference between the Gross enrolment ratio (%) in Sub-Saharan Africa (all income levels) in 1980 and the Gross enrolment ratio (%) in Nicaragua in 1984?
Provide a short and direct response. -7.7. What is the difference between the Gross enrolment ratio (%) in Sub-Saharan Africa (all income levels) in 1980 and the Gross enrolment ratio (%) in Qatar in 1984?
Provide a succinct answer. -35.58. What is the difference between the Gross enrolment ratio (%) in Nicaragua in 1980 and the Gross enrolment ratio (%) in Qatar in 1984?
Ensure brevity in your answer.  -27.41. What is the difference between the Gross enrolment ratio (%) in Fragile and conflict affected situations in 1982 and the Gross enrolment ratio (%) in Sub-Saharan Africa (all income levels) in 1983?
Your response must be concise. -2.37. What is the difference between the Gross enrolment ratio (%) in Fragile and conflict affected situations in 1982 and the Gross enrolment ratio (%) in Nicaragua in 1983?
Your answer should be very brief. -8.64. What is the difference between the Gross enrolment ratio (%) in Fragile and conflict affected situations in 1982 and the Gross enrolment ratio (%) in Qatar in 1983?
Your answer should be compact. -39.19. What is the difference between the Gross enrolment ratio (%) in Sub-Saharan Africa (all income levels) in 1982 and the Gross enrolment ratio (%) in Nicaragua in 1983?
Offer a very short reply. -6.02. What is the difference between the Gross enrolment ratio (%) of Sub-Saharan Africa (all income levels) in 1982 and the Gross enrolment ratio (%) of Qatar in 1983?
Your answer should be compact. -36.58. What is the difference between the Gross enrolment ratio (%) in Nicaragua in 1982 and the Gross enrolment ratio (%) in Qatar in 1983?
Offer a very short reply. -32.35. What is the difference between the Gross enrolment ratio (%) of Fragile and conflict affected situations in 1982 and the Gross enrolment ratio (%) of Sub-Saharan Africa (all income levels) in 1984?
Ensure brevity in your answer.  -1.32. What is the difference between the Gross enrolment ratio (%) of Fragile and conflict affected situations in 1982 and the Gross enrolment ratio (%) of Nicaragua in 1984?
Provide a short and direct response. -5.69. What is the difference between the Gross enrolment ratio (%) in Fragile and conflict affected situations in 1982 and the Gross enrolment ratio (%) in Qatar in 1984?
Your response must be concise. -33.56. What is the difference between the Gross enrolment ratio (%) of Sub-Saharan Africa (all income levels) in 1982 and the Gross enrolment ratio (%) of Nicaragua in 1984?
Make the answer very short. -3.07. What is the difference between the Gross enrolment ratio (%) in Sub-Saharan Africa (all income levels) in 1982 and the Gross enrolment ratio (%) in Qatar in 1984?
Offer a very short reply. -30.95. What is the difference between the Gross enrolment ratio (%) in Nicaragua in 1982 and the Gross enrolment ratio (%) in Qatar in 1984?
Give a very brief answer. -26.73. What is the difference between the Gross enrolment ratio (%) of Fragile and conflict affected situations in 1983 and the Gross enrolment ratio (%) of Sub-Saharan Africa (all income levels) in 1984?
Your answer should be very brief. -0.91. What is the difference between the Gross enrolment ratio (%) in Fragile and conflict affected situations in 1983 and the Gross enrolment ratio (%) in Nicaragua in 1984?
Provide a short and direct response. -5.28. What is the difference between the Gross enrolment ratio (%) of Fragile and conflict affected situations in 1983 and the Gross enrolment ratio (%) of Qatar in 1984?
Offer a very short reply. -33.16. What is the difference between the Gross enrolment ratio (%) in Sub-Saharan Africa (all income levels) in 1983 and the Gross enrolment ratio (%) in Nicaragua in 1984?
Your answer should be very brief. -3.32. What is the difference between the Gross enrolment ratio (%) in Sub-Saharan Africa (all income levels) in 1983 and the Gross enrolment ratio (%) in Qatar in 1984?
Provide a short and direct response. -31.19. What is the difference between the Gross enrolment ratio (%) in Nicaragua in 1983 and the Gross enrolment ratio (%) in Qatar in 1984?
Provide a short and direct response. -24.92. What is the average Gross enrolment ratio (%) in Fragile and conflict affected situations per year?
Give a very brief answer. 77.13. What is the average Gross enrolment ratio (%) of Sub-Saharan Africa (all income levels) per year?
Your answer should be compact. 76.11. What is the average Gross enrolment ratio (%) of Nicaragua per year?
Offer a terse response. 81.21. What is the average Gross enrolment ratio (%) in Qatar per year?
Provide a short and direct response. 119.98. In the year 1977, what is the difference between the Gross enrolment ratio (%) in Fragile and conflict affected situations and Gross enrolment ratio (%) in Sub-Saharan Africa (all income levels)?
Make the answer very short. 6.96. In the year 1977, what is the difference between the Gross enrolment ratio (%) of Fragile and conflict affected situations and Gross enrolment ratio (%) of Nicaragua?
Offer a terse response. -0.83. In the year 1977, what is the difference between the Gross enrolment ratio (%) of Fragile and conflict affected situations and Gross enrolment ratio (%) of Qatar?
Your response must be concise. -50.47. In the year 1977, what is the difference between the Gross enrolment ratio (%) of Sub-Saharan Africa (all income levels) and Gross enrolment ratio (%) of Nicaragua?
Ensure brevity in your answer.  -7.79. In the year 1977, what is the difference between the Gross enrolment ratio (%) of Sub-Saharan Africa (all income levels) and Gross enrolment ratio (%) of Qatar?
Make the answer very short. -57.43. In the year 1977, what is the difference between the Gross enrolment ratio (%) of Nicaragua and Gross enrolment ratio (%) of Qatar?
Offer a terse response. -49.64. In the year 1978, what is the difference between the Gross enrolment ratio (%) of Fragile and conflict affected situations and Gross enrolment ratio (%) of Sub-Saharan Africa (all income levels)?
Ensure brevity in your answer.  3.64. In the year 1978, what is the difference between the Gross enrolment ratio (%) of Fragile and conflict affected situations and Gross enrolment ratio (%) of Nicaragua?
Your answer should be very brief. 1.69. In the year 1978, what is the difference between the Gross enrolment ratio (%) in Fragile and conflict affected situations and Gross enrolment ratio (%) in Qatar?
Keep it short and to the point. -48.86. In the year 1978, what is the difference between the Gross enrolment ratio (%) of Sub-Saharan Africa (all income levels) and Gross enrolment ratio (%) of Nicaragua?
Provide a succinct answer. -1.95. In the year 1978, what is the difference between the Gross enrolment ratio (%) in Sub-Saharan Africa (all income levels) and Gross enrolment ratio (%) in Qatar?
Your response must be concise. -52.51. In the year 1978, what is the difference between the Gross enrolment ratio (%) of Nicaragua and Gross enrolment ratio (%) of Qatar?
Offer a very short reply. -50.56. In the year 1979, what is the difference between the Gross enrolment ratio (%) of Fragile and conflict affected situations and Gross enrolment ratio (%) of Sub-Saharan Africa (all income levels)?
Ensure brevity in your answer.  1.07. In the year 1979, what is the difference between the Gross enrolment ratio (%) of Fragile and conflict affected situations and Gross enrolment ratio (%) of Nicaragua?
Give a very brief answer. -1.81. In the year 1979, what is the difference between the Gross enrolment ratio (%) in Fragile and conflict affected situations and Gross enrolment ratio (%) in Qatar?
Offer a terse response. -46.23. In the year 1979, what is the difference between the Gross enrolment ratio (%) of Sub-Saharan Africa (all income levels) and Gross enrolment ratio (%) of Nicaragua?
Make the answer very short. -2.88. In the year 1979, what is the difference between the Gross enrolment ratio (%) of Sub-Saharan Africa (all income levels) and Gross enrolment ratio (%) of Qatar?
Your response must be concise. -47.3. In the year 1979, what is the difference between the Gross enrolment ratio (%) in Nicaragua and Gross enrolment ratio (%) in Qatar?
Provide a short and direct response. -44.42. In the year 1980, what is the difference between the Gross enrolment ratio (%) in Fragile and conflict affected situations and Gross enrolment ratio (%) in Sub-Saharan Africa (all income levels)?
Give a very brief answer. 0.65. In the year 1980, what is the difference between the Gross enrolment ratio (%) of Fragile and conflict affected situations and Gross enrolment ratio (%) of Nicaragua?
Give a very brief answer. -7.52. In the year 1980, what is the difference between the Gross enrolment ratio (%) of Fragile and conflict affected situations and Gross enrolment ratio (%) of Qatar?
Your answer should be compact. -42.52. In the year 1980, what is the difference between the Gross enrolment ratio (%) of Sub-Saharan Africa (all income levels) and Gross enrolment ratio (%) of Nicaragua?
Keep it short and to the point. -8.16. In the year 1980, what is the difference between the Gross enrolment ratio (%) of Sub-Saharan Africa (all income levels) and Gross enrolment ratio (%) of Qatar?
Offer a very short reply. -43.17. In the year 1980, what is the difference between the Gross enrolment ratio (%) in Nicaragua and Gross enrolment ratio (%) in Qatar?
Keep it short and to the point. -35.01. In the year 1982, what is the difference between the Gross enrolment ratio (%) of Fragile and conflict affected situations and Gross enrolment ratio (%) of Sub-Saharan Africa (all income levels)?
Offer a very short reply. -2.62. In the year 1982, what is the difference between the Gross enrolment ratio (%) of Fragile and conflict affected situations and Gross enrolment ratio (%) of Nicaragua?
Provide a succinct answer. -6.84. In the year 1982, what is the difference between the Gross enrolment ratio (%) of Fragile and conflict affected situations and Gross enrolment ratio (%) of Qatar?
Offer a very short reply. -40.18. In the year 1982, what is the difference between the Gross enrolment ratio (%) of Sub-Saharan Africa (all income levels) and Gross enrolment ratio (%) of Nicaragua?
Offer a terse response. -4.22. In the year 1982, what is the difference between the Gross enrolment ratio (%) in Sub-Saharan Africa (all income levels) and Gross enrolment ratio (%) in Qatar?
Your answer should be compact. -37.56. In the year 1982, what is the difference between the Gross enrolment ratio (%) of Nicaragua and Gross enrolment ratio (%) of Qatar?
Offer a terse response. -33.34. In the year 1983, what is the difference between the Gross enrolment ratio (%) of Fragile and conflict affected situations and Gross enrolment ratio (%) of Sub-Saharan Africa (all income levels)?
Make the answer very short. -1.96. In the year 1983, what is the difference between the Gross enrolment ratio (%) of Fragile and conflict affected situations and Gross enrolment ratio (%) of Nicaragua?
Your answer should be compact. -8.23. In the year 1983, what is the difference between the Gross enrolment ratio (%) of Fragile and conflict affected situations and Gross enrolment ratio (%) of Qatar?
Provide a succinct answer. -38.78. In the year 1983, what is the difference between the Gross enrolment ratio (%) of Sub-Saharan Africa (all income levels) and Gross enrolment ratio (%) of Nicaragua?
Provide a short and direct response. -6.27. In the year 1983, what is the difference between the Gross enrolment ratio (%) of Sub-Saharan Africa (all income levels) and Gross enrolment ratio (%) of Qatar?
Provide a succinct answer. -36.82. In the year 1983, what is the difference between the Gross enrolment ratio (%) of Nicaragua and Gross enrolment ratio (%) of Qatar?
Provide a succinct answer. -30.55. In the year 1984, what is the difference between the Gross enrolment ratio (%) in Fragile and conflict affected situations and Gross enrolment ratio (%) in Sub-Saharan Africa (all income levels)?
Offer a terse response. -0.61. In the year 1984, what is the difference between the Gross enrolment ratio (%) of Fragile and conflict affected situations and Gross enrolment ratio (%) of Nicaragua?
Keep it short and to the point. -4.98. In the year 1984, what is the difference between the Gross enrolment ratio (%) in Fragile and conflict affected situations and Gross enrolment ratio (%) in Qatar?
Your response must be concise. -32.86. In the year 1984, what is the difference between the Gross enrolment ratio (%) in Sub-Saharan Africa (all income levels) and Gross enrolment ratio (%) in Nicaragua?
Your response must be concise. -4.37. In the year 1984, what is the difference between the Gross enrolment ratio (%) of Sub-Saharan Africa (all income levels) and Gross enrolment ratio (%) of Qatar?
Your answer should be very brief. -32.25. In the year 1984, what is the difference between the Gross enrolment ratio (%) in Nicaragua and Gross enrolment ratio (%) in Qatar?
Provide a succinct answer. -27.88. What is the ratio of the Gross enrolment ratio (%) of Fragile and conflict affected situations in 1977 to that in 1978?
Your answer should be very brief. 1. What is the ratio of the Gross enrolment ratio (%) in Sub-Saharan Africa (all income levels) in 1977 to that in 1978?
Keep it short and to the point. 0.95. What is the ratio of the Gross enrolment ratio (%) of Nicaragua in 1977 to that in 1978?
Give a very brief answer. 1.03. What is the ratio of the Gross enrolment ratio (%) of Qatar in 1977 to that in 1978?
Make the answer very short. 1.01. What is the ratio of the Gross enrolment ratio (%) of Fragile and conflict affected situations in 1977 to that in 1979?
Keep it short and to the point. 0.97. What is the ratio of the Gross enrolment ratio (%) of Sub-Saharan Africa (all income levels) in 1977 to that in 1979?
Make the answer very short. 0.89. What is the ratio of the Gross enrolment ratio (%) in Nicaragua in 1977 to that in 1979?
Make the answer very short. 0.96. What is the ratio of the Gross enrolment ratio (%) of Qatar in 1977 to that in 1979?
Provide a succinct answer. 1.02. What is the ratio of the Gross enrolment ratio (%) in Fragile and conflict affected situations in 1977 to that in 1980?
Give a very brief answer. 0.94. What is the ratio of the Gross enrolment ratio (%) of Sub-Saharan Africa (all income levels) in 1977 to that in 1980?
Provide a short and direct response. 0.86. What is the ratio of the Gross enrolment ratio (%) of Nicaragua in 1977 to that in 1980?
Provide a succinct answer. 0.86. What is the ratio of the Gross enrolment ratio (%) in Qatar in 1977 to that in 1980?
Your response must be concise. 1.03. What is the ratio of the Gross enrolment ratio (%) in Fragile and conflict affected situations in 1977 to that in 1982?
Provide a short and direct response. 0.92. What is the ratio of the Gross enrolment ratio (%) of Sub-Saharan Africa (all income levels) in 1977 to that in 1982?
Your answer should be compact. 0.81. What is the ratio of the Gross enrolment ratio (%) of Nicaragua in 1977 to that in 1982?
Your answer should be compact. 0.86. What is the ratio of the Gross enrolment ratio (%) of Qatar in 1977 to that in 1982?
Offer a terse response. 1.03. What is the ratio of the Gross enrolment ratio (%) in Fragile and conflict affected situations in 1977 to that in 1983?
Provide a short and direct response. 0.92. What is the ratio of the Gross enrolment ratio (%) of Sub-Saharan Africa (all income levels) in 1977 to that in 1983?
Make the answer very short. 0.81. What is the ratio of the Gross enrolment ratio (%) of Nicaragua in 1977 to that in 1983?
Keep it short and to the point. 0.84. What is the ratio of the Gross enrolment ratio (%) of Qatar in 1977 to that in 1983?
Ensure brevity in your answer.  1.04. What is the ratio of the Gross enrolment ratio (%) of Fragile and conflict affected situations in 1977 to that in 1984?
Your answer should be very brief. 0.91. What is the ratio of the Gross enrolment ratio (%) in Sub-Saharan Africa (all income levels) in 1977 to that in 1984?
Your response must be concise. 0.82. What is the ratio of the Gross enrolment ratio (%) in Nicaragua in 1977 to that in 1984?
Make the answer very short. 0.87. What is the ratio of the Gross enrolment ratio (%) in Qatar in 1977 to that in 1984?
Your answer should be very brief. 1.09. What is the ratio of the Gross enrolment ratio (%) in Fragile and conflict affected situations in 1978 to that in 1979?
Provide a succinct answer. 0.97. What is the ratio of the Gross enrolment ratio (%) of Sub-Saharan Africa (all income levels) in 1978 to that in 1979?
Your response must be concise. 0.94. What is the ratio of the Gross enrolment ratio (%) in Nicaragua in 1978 to that in 1979?
Your response must be concise. 0.93. What is the ratio of the Gross enrolment ratio (%) of Qatar in 1978 to that in 1979?
Provide a short and direct response. 1.01. What is the ratio of the Gross enrolment ratio (%) in Fragile and conflict affected situations in 1978 to that in 1980?
Ensure brevity in your answer.  0.94. What is the ratio of the Gross enrolment ratio (%) of Sub-Saharan Africa (all income levels) in 1978 to that in 1980?
Offer a very short reply. 0.9. What is the ratio of the Gross enrolment ratio (%) of Nicaragua in 1978 to that in 1980?
Give a very brief answer. 0.84. What is the ratio of the Gross enrolment ratio (%) of Qatar in 1978 to that in 1980?
Provide a succinct answer. 1.01. What is the ratio of the Gross enrolment ratio (%) of Fragile and conflict affected situations in 1978 to that in 1982?
Offer a very short reply. 0.93. What is the ratio of the Gross enrolment ratio (%) of Sub-Saharan Africa (all income levels) in 1978 to that in 1982?
Make the answer very short. 0.85. What is the ratio of the Gross enrolment ratio (%) in Nicaragua in 1978 to that in 1982?
Offer a very short reply. 0.83. What is the ratio of the Gross enrolment ratio (%) of Qatar in 1978 to that in 1982?
Give a very brief answer. 1.02. What is the ratio of the Gross enrolment ratio (%) in Fragile and conflict affected situations in 1978 to that in 1983?
Offer a very short reply. 0.92. What is the ratio of the Gross enrolment ratio (%) in Sub-Saharan Africa (all income levels) in 1978 to that in 1983?
Provide a short and direct response. 0.85. What is the ratio of the Gross enrolment ratio (%) in Nicaragua in 1978 to that in 1983?
Offer a very short reply. 0.82. What is the ratio of the Gross enrolment ratio (%) of Qatar in 1978 to that in 1983?
Your answer should be very brief. 1.03. What is the ratio of the Gross enrolment ratio (%) of Fragile and conflict affected situations in 1978 to that in 1984?
Ensure brevity in your answer.  0.92. What is the ratio of the Gross enrolment ratio (%) in Sub-Saharan Africa (all income levels) in 1978 to that in 1984?
Offer a terse response. 0.87. What is the ratio of the Gross enrolment ratio (%) in Nicaragua in 1978 to that in 1984?
Provide a short and direct response. 0.84. What is the ratio of the Gross enrolment ratio (%) in Qatar in 1978 to that in 1984?
Your answer should be compact. 1.08. What is the ratio of the Gross enrolment ratio (%) in Fragile and conflict affected situations in 1979 to that in 1980?
Your answer should be very brief. 0.97. What is the ratio of the Gross enrolment ratio (%) in Sub-Saharan Africa (all income levels) in 1979 to that in 1980?
Give a very brief answer. 0.96. What is the ratio of the Gross enrolment ratio (%) of Nicaragua in 1979 to that in 1980?
Give a very brief answer. 0.9. What is the ratio of the Gross enrolment ratio (%) in Qatar in 1979 to that in 1980?
Provide a succinct answer. 1.01. What is the ratio of the Gross enrolment ratio (%) in Fragile and conflict affected situations in 1979 to that in 1982?
Make the answer very short. 0.95. What is the ratio of the Gross enrolment ratio (%) of Sub-Saharan Africa (all income levels) in 1979 to that in 1982?
Keep it short and to the point. 0.91. What is the ratio of the Gross enrolment ratio (%) in Nicaragua in 1979 to that in 1982?
Ensure brevity in your answer.  0.9. What is the ratio of the Gross enrolment ratio (%) in Qatar in 1979 to that in 1982?
Give a very brief answer. 1.02. What is the ratio of the Gross enrolment ratio (%) in Fragile and conflict affected situations in 1979 to that in 1983?
Provide a succinct answer. 0.94. What is the ratio of the Gross enrolment ratio (%) in Sub-Saharan Africa (all income levels) in 1979 to that in 1983?
Ensure brevity in your answer.  0.91. What is the ratio of the Gross enrolment ratio (%) of Nicaragua in 1979 to that in 1983?
Offer a very short reply. 0.88. What is the ratio of the Gross enrolment ratio (%) in Qatar in 1979 to that in 1983?
Keep it short and to the point. 1.03. What is the ratio of the Gross enrolment ratio (%) in Fragile and conflict affected situations in 1979 to that in 1984?
Give a very brief answer. 0.94. What is the ratio of the Gross enrolment ratio (%) of Sub-Saharan Africa (all income levels) in 1979 to that in 1984?
Your response must be concise. 0.92. What is the ratio of the Gross enrolment ratio (%) of Nicaragua in 1979 to that in 1984?
Offer a terse response. 0.91. What is the ratio of the Gross enrolment ratio (%) in Qatar in 1979 to that in 1984?
Provide a succinct answer. 1.08. What is the ratio of the Gross enrolment ratio (%) of Fragile and conflict affected situations in 1980 to that in 1982?
Give a very brief answer. 0.98. What is the ratio of the Gross enrolment ratio (%) of Sub-Saharan Africa (all income levels) in 1980 to that in 1982?
Ensure brevity in your answer.  0.94. What is the ratio of the Gross enrolment ratio (%) of Nicaragua in 1980 to that in 1982?
Your answer should be compact. 0.99. What is the ratio of the Gross enrolment ratio (%) in Qatar in 1980 to that in 1982?
Keep it short and to the point. 1.01. What is the ratio of the Gross enrolment ratio (%) in Fragile and conflict affected situations in 1980 to that in 1983?
Your answer should be compact. 0.98. What is the ratio of the Gross enrolment ratio (%) of Sub-Saharan Africa (all income levels) in 1980 to that in 1983?
Make the answer very short. 0.95. What is the ratio of the Gross enrolment ratio (%) in Nicaragua in 1980 to that in 1983?
Your answer should be compact. 0.97. What is the ratio of the Gross enrolment ratio (%) of Qatar in 1980 to that in 1983?
Give a very brief answer. 1.02. What is the ratio of the Gross enrolment ratio (%) in Fragile and conflict affected situations in 1980 to that in 1984?
Your answer should be very brief. 0.97. What is the ratio of the Gross enrolment ratio (%) of Sub-Saharan Africa (all income levels) in 1980 to that in 1984?
Your answer should be very brief. 0.96. What is the ratio of the Gross enrolment ratio (%) in Nicaragua in 1980 to that in 1984?
Give a very brief answer. 1.01. What is the ratio of the Gross enrolment ratio (%) of Qatar in 1980 to that in 1984?
Keep it short and to the point. 1.07. What is the ratio of the Gross enrolment ratio (%) of Fragile and conflict affected situations in 1982 to that in 1983?
Keep it short and to the point. 0.99. What is the ratio of the Gross enrolment ratio (%) in Nicaragua in 1982 to that in 1983?
Offer a very short reply. 0.98. What is the ratio of the Gross enrolment ratio (%) in Qatar in 1982 to that in 1983?
Give a very brief answer. 1.01. What is the ratio of the Gross enrolment ratio (%) in Fragile and conflict affected situations in 1982 to that in 1984?
Your answer should be very brief. 0.99. What is the ratio of the Gross enrolment ratio (%) in Sub-Saharan Africa (all income levels) in 1982 to that in 1984?
Offer a very short reply. 1.02. What is the ratio of the Gross enrolment ratio (%) of Nicaragua in 1982 to that in 1984?
Your answer should be compact. 1.01. What is the ratio of the Gross enrolment ratio (%) in Qatar in 1982 to that in 1984?
Keep it short and to the point. 1.06. What is the ratio of the Gross enrolment ratio (%) of Sub-Saharan Africa (all income levels) in 1983 to that in 1984?
Provide a short and direct response. 1.01. What is the ratio of the Gross enrolment ratio (%) of Nicaragua in 1983 to that in 1984?
Give a very brief answer. 1.03. What is the ratio of the Gross enrolment ratio (%) in Qatar in 1983 to that in 1984?
Offer a terse response. 1.05. What is the difference between the highest and the second highest Gross enrolment ratio (%) of Fragile and conflict affected situations?
Give a very brief answer. 0.3. What is the difference between the highest and the second highest Gross enrolment ratio (%) of Sub-Saharan Africa (all income levels)?
Offer a very short reply. 0.24. What is the difference between the highest and the second highest Gross enrolment ratio (%) of Nicaragua?
Make the answer very short. 1.8. What is the difference between the highest and the second highest Gross enrolment ratio (%) of Qatar?
Your answer should be very brief. 1.27. What is the difference between the highest and the lowest Gross enrolment ratio (%) of Fragile and conflict affected situations?
Offer a very short reply. 6.98. What is the difference between the highest and the lowest Gross enrolment ratio (%) of Sub-Saharan Africa (all income levels)?
Ensure brevity in your answer.  15.86. What is the difference between the highest and the lowest Gross enrolment ratio (%) of Nicaragua?
Offer a very short reply. 16.27. What is the difference between the highest and the lowest Gross enrolment ratio (%) of Qatar?
Your answer should be compact. 10.63. 